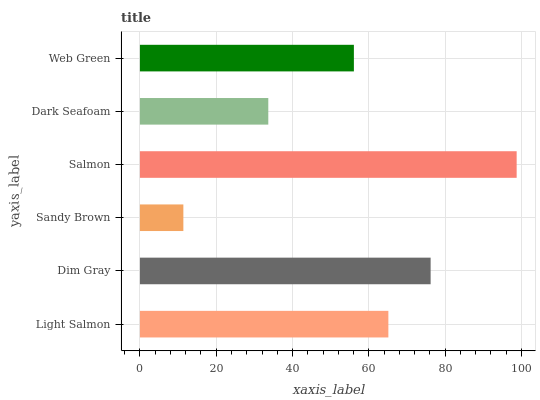Is Sandy Brown the minimum?
Answer yes or no. Yes. Is Salmon the maximum?
Answer yes or no. Yes. Is Dim Gray the minimum?
Answer yes or no. No. Is Dim Gray the maximum?
Answer yes or no. No. Is Dim Gray greater than Light Salmon?
Answer yes or no. Yes. Is Light Salmon less than Dim Gray?
Answer yes or no. Yes. Is Light Salmon greater than Dim Gray?
Answer yes or no. No. Is Dim Gray less than Light Salmon?
Answer yes or no. No. Is Light Salmon the high median?
Answer yes or no. Yes. Is Web Green the low median?
Answer yes or no. Yes. Is Dim Gray the high median?
Answer yes or no. No. Is Sandy Brown the low median?
Answer yes or no. No. 